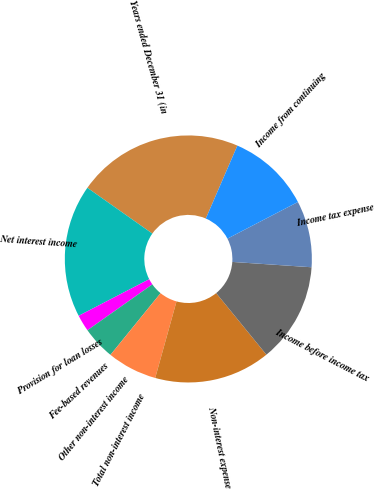Convert chart to OTSL. <chart><loc_0><loc_0><loc_500><loc_500><pie_chart><fcel>Years ended December 31 (in<fcel>Net interest income<fcel>Provision for loan losses<fcel>Fee-based revenues<fcel>Other non-interest income<fcel>Total non-interest income<fcel>Non-interest expense<fcel>Income before income tax<fcel>Income tax expense<fcel>Income from continuing<nl><fcel>21.73%<fcel>17.38%<fcel>2.18%<fcel>4.35%<fcel>0.01%<fcel>6.53%<fcel>15.21%<fcel>13.04%<fcel>8.7%<fcel>10.87%<nl></chart> 